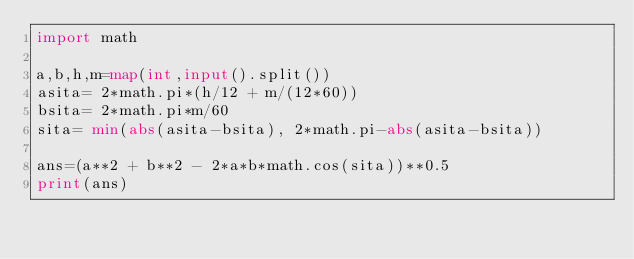<code> <loc_0><loc_0><loc_500><loc_500><_Python_>import math

a,b,h,m=map(int,input().split())
asita= 2*math.pi*(h/12 + m/(12*60))
bsita= 2*math.pi*m/60
sita= min(abs(asita-bsita), 2*math.pi-abs(asita-bsita))

ans=(a**2 + b**2 - 2*a*b*math.cos(sita))**0.5
print(ans)</code> 